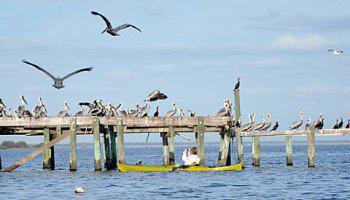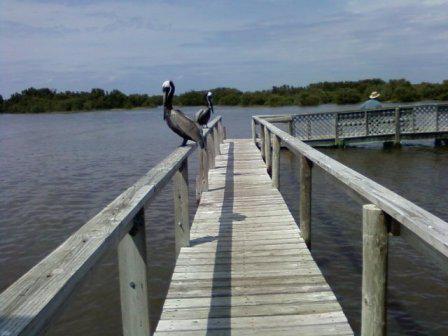The first image is the image on the left, the second image is the image on the right. Evaluate the accuracy of this statement regarding the images: "At least one pelican is flying.". Is it true? Answer yes or no. Yes. The first image is the image on the left, the second image is the image on the right. Evaluate the accuracy of this statement regarding the images: "One image includes pelicans on a wooden pier, and the other image shows at least one pelican in the water.". Is it true? Answer yes or no. No. 